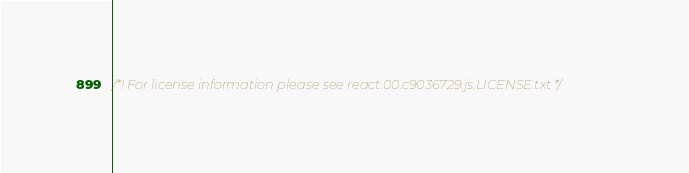Convert code to text. <code><loc_0><loc_0><loc_500><loc_500><_JavaScript_>/*! For license information please see react.00.c9036729.js.LICENSE.txt */</code> 